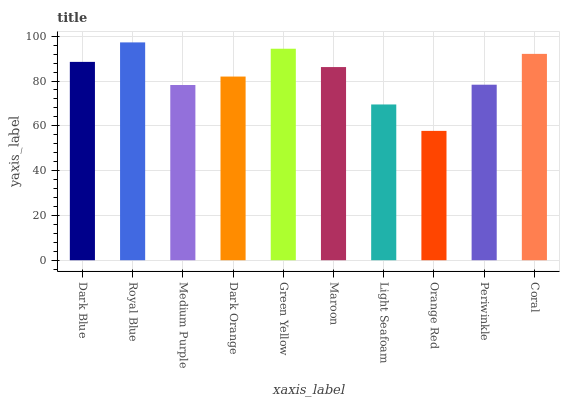Is Orange Red the minimum?
Answer yes or no. Yes. Is Royal Blue the maximum?
Answer yes or no. Yes. Is Medium Purple the minimum?
Answer yes or no. No. Is Medium Purple the maximum?
Answer yes or no. No. Is Royal Blue greater than Medium Purple?
Answer yes or no. Yes. Is Medium Purple less than Royal Blue?
Answer yes or no. Yes. Is Medium Purple greater than Royal Blue?
Answer yes or no. No. Is Royal Blue less than Medium Purple?
Answer yes or no. No. Is Maroon the high median?
Answer yes or no. Yes. Is Dark Orange the low median?
Answer yes or no. Yes. Is Green Yellow the high median?
Answer yes or no. No. Is Dark Blue the low median?
Answer yes or no. No. 